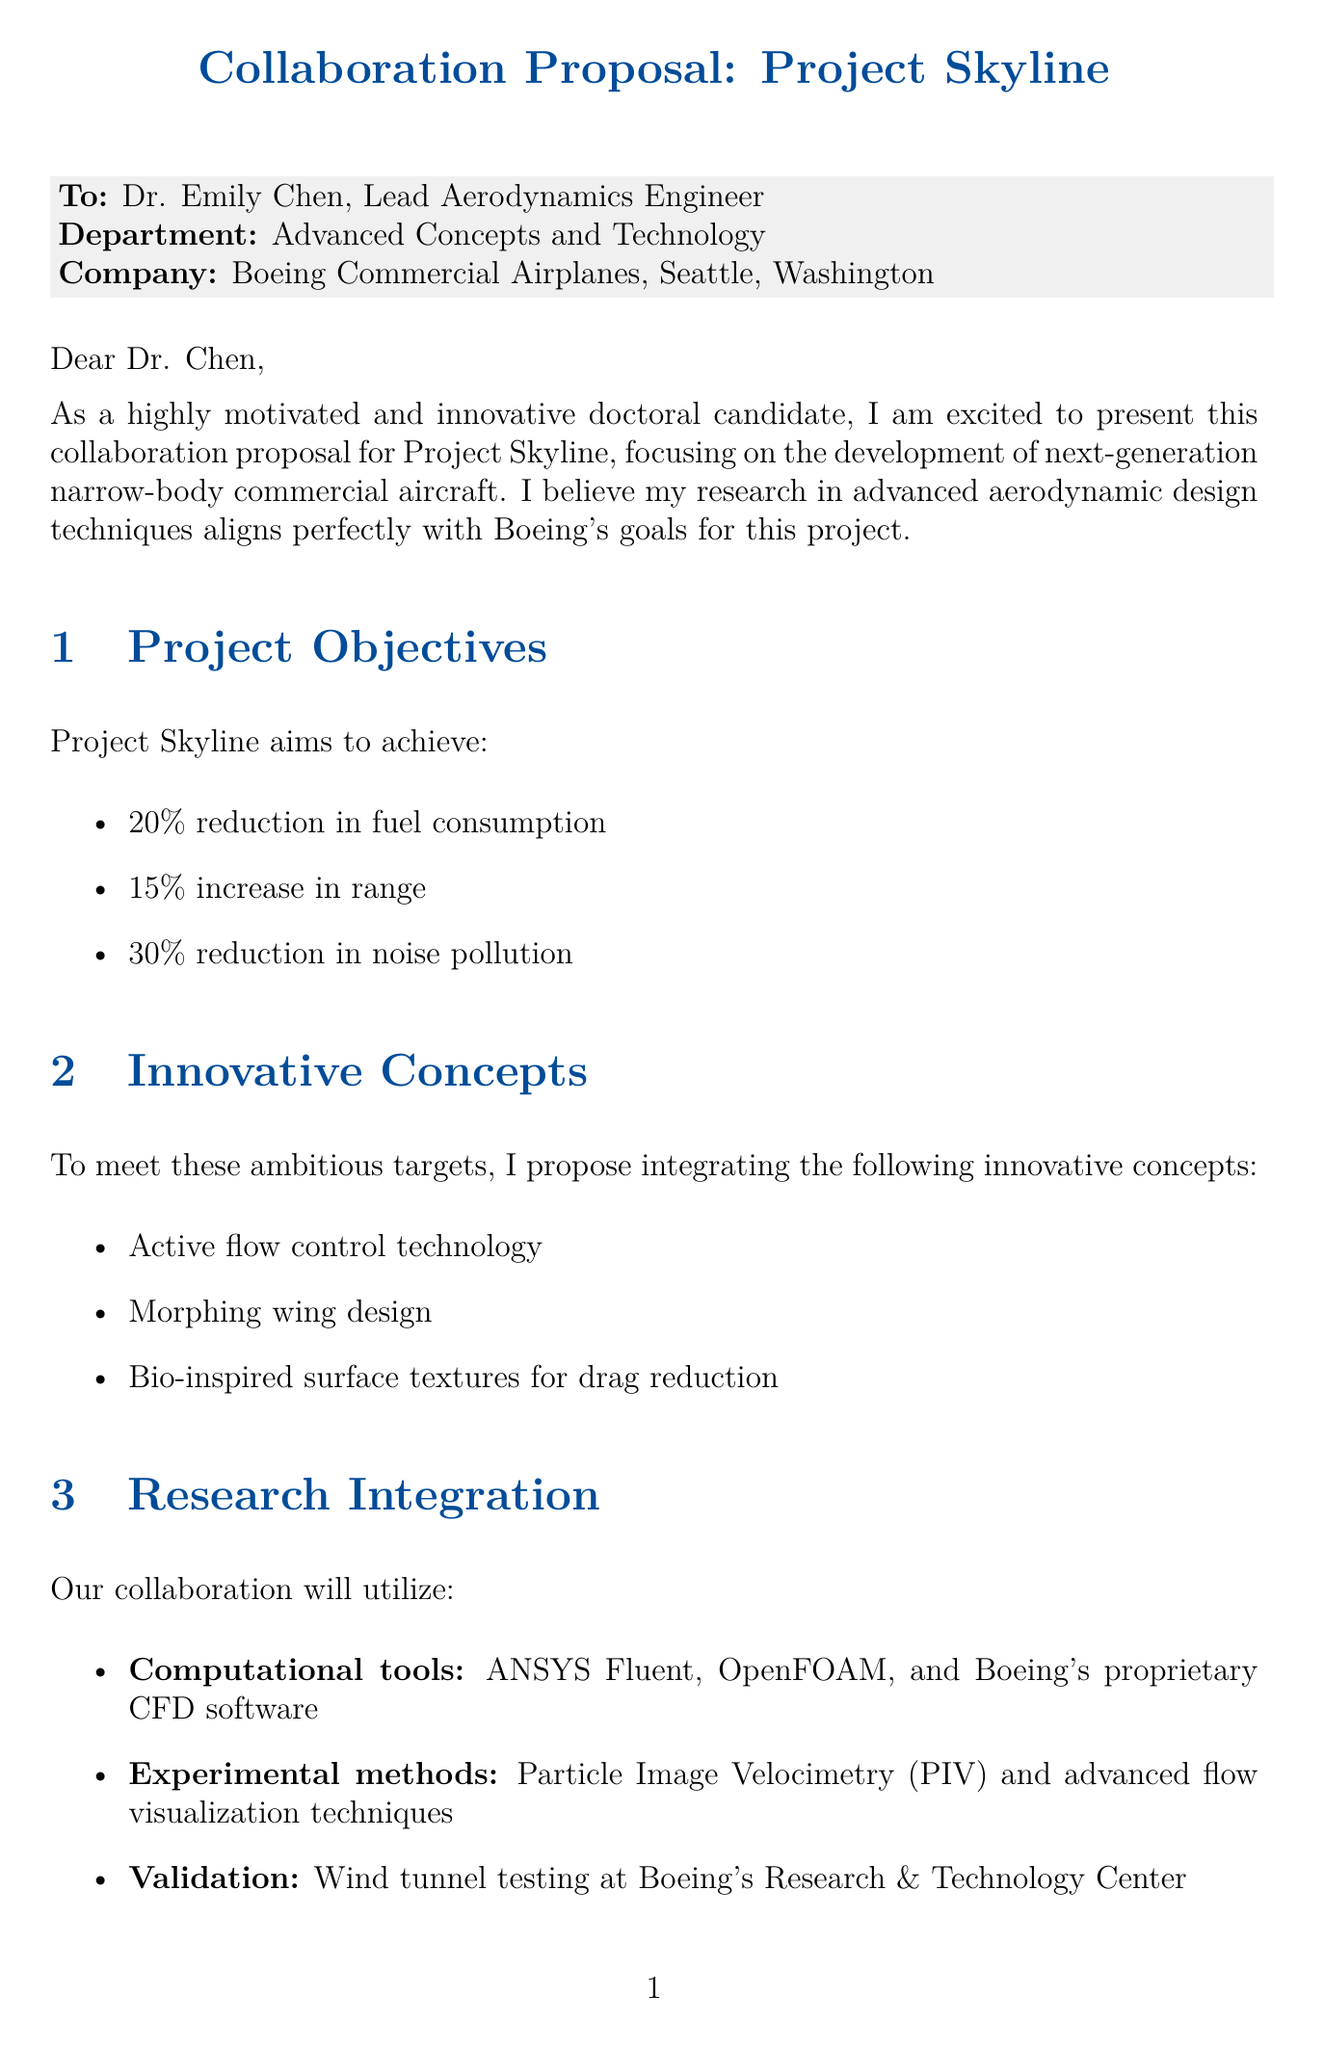What is the name of the project? The project is referred to as Project Skyline in the document.
Answer: Project Skyline Who is the contact person at Boeing? Dr. Emily Chen is mentioned as the Lead Aerodynamics Engineer and contact person in the letter.
Answer: Dr. Emily Chen How long is the project duration? The total duration of the project is specified in the document as 18 months.
Answer: 18 months What is the target reduction in fuel consumption? The document states the goal is a 20% reduction in fuel consumption.
Answer: 20% Which experimental method will be used for validation? The letter lists Particle Image Velocimetry (PIV) as one of the experimental methods for validation.
Answer: Particle Image Velocimetry (PIV) What stipend amount is offered for the collaboration? The collaboration includes a stipend amount mentioned as $40,000 per year.
Answer: $40,000 What is a potential outcome of the collaboration regarding intellectual property? Joint ownership between the doctoral candidate and Boeing is mentioned in the context of intellectual property.
Answer: Joint ownership What is one of the benefits of the collaboration? Access to Boeing's state-of-the-art wind tunnel facilities is listed as one of the collaboration benefits.
Answer: Access to Boeing's state-of-the-art wind tunnel facilities Which journal is mentioned for potential publications? The document indicates the Journal of Fluid Mechanics as one of the potential publication outlets.
Answer: Journal of Fluid Mechanics 